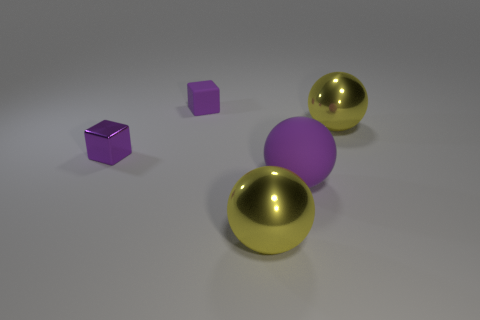Add 3 small gray rubber spheres. How many objects exist? 8 Subtract all cubes. How many objects are left? 3 Subtract 0 red spheres. How many objects are left? 5 Subtract all rubber spheres. Subtract all metal spheres. How many objects are left? 2 Add 1 big yellow metallic spheres. How many big yellow metallic spheres are left? 3 Add 3 small blocks. How many small blocks exist? 5 